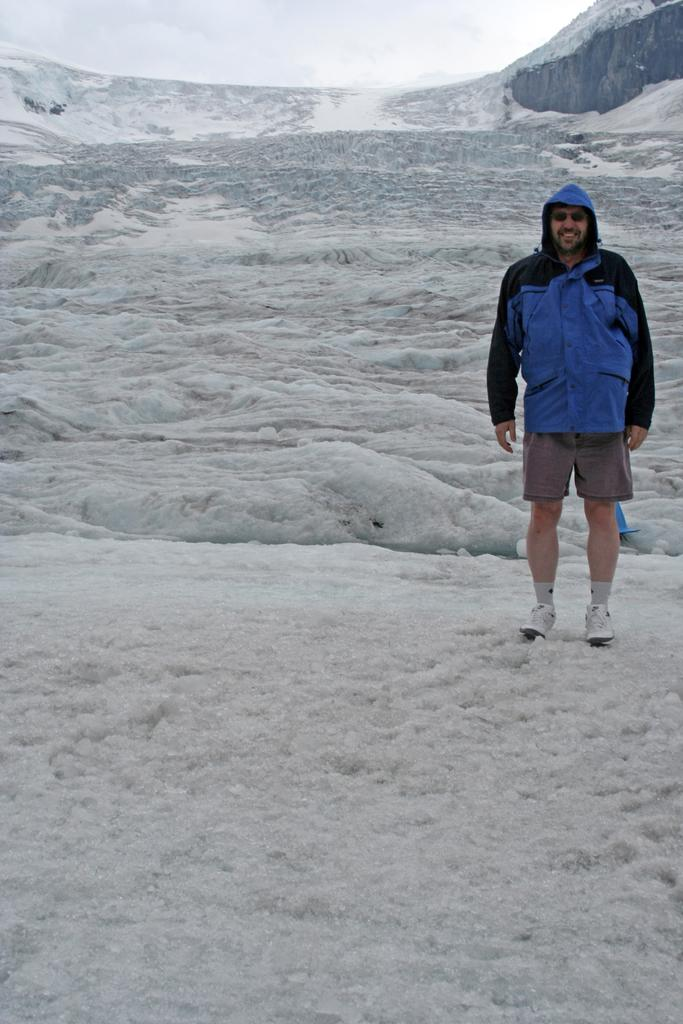What is the main subject of the image? There is a person standing in the middle of the image. What is the person's expression in the image? The person is smiling in the image. What type of landscape can be seen behind the person? There are hills visible behind the person. What is visible at the top of the image? There are clouds at the top of the image. What type of zinc can be seen in the image? There is no zinc present in the image. How is the fuel being used by the person in the image? There is no fuel or indication of its use in the image. 